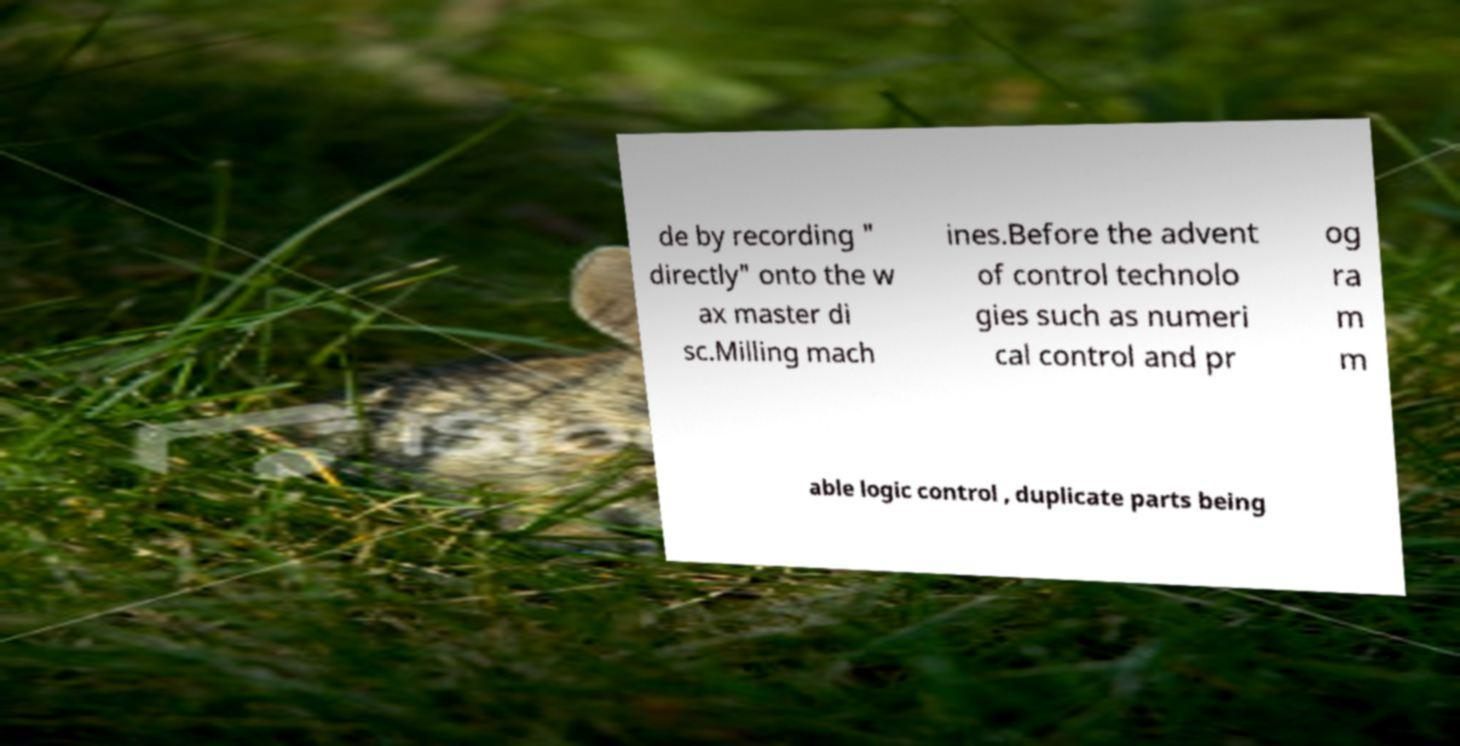For documentation purposes, I need the text within this image transcribed. Could you provide that? de by recording " directly" onto the w ax master di sc.Milling mach ines.Before the advent of control technolo gies such as numeri cal control and pr og ra m m able logic control , duplicate parts being 